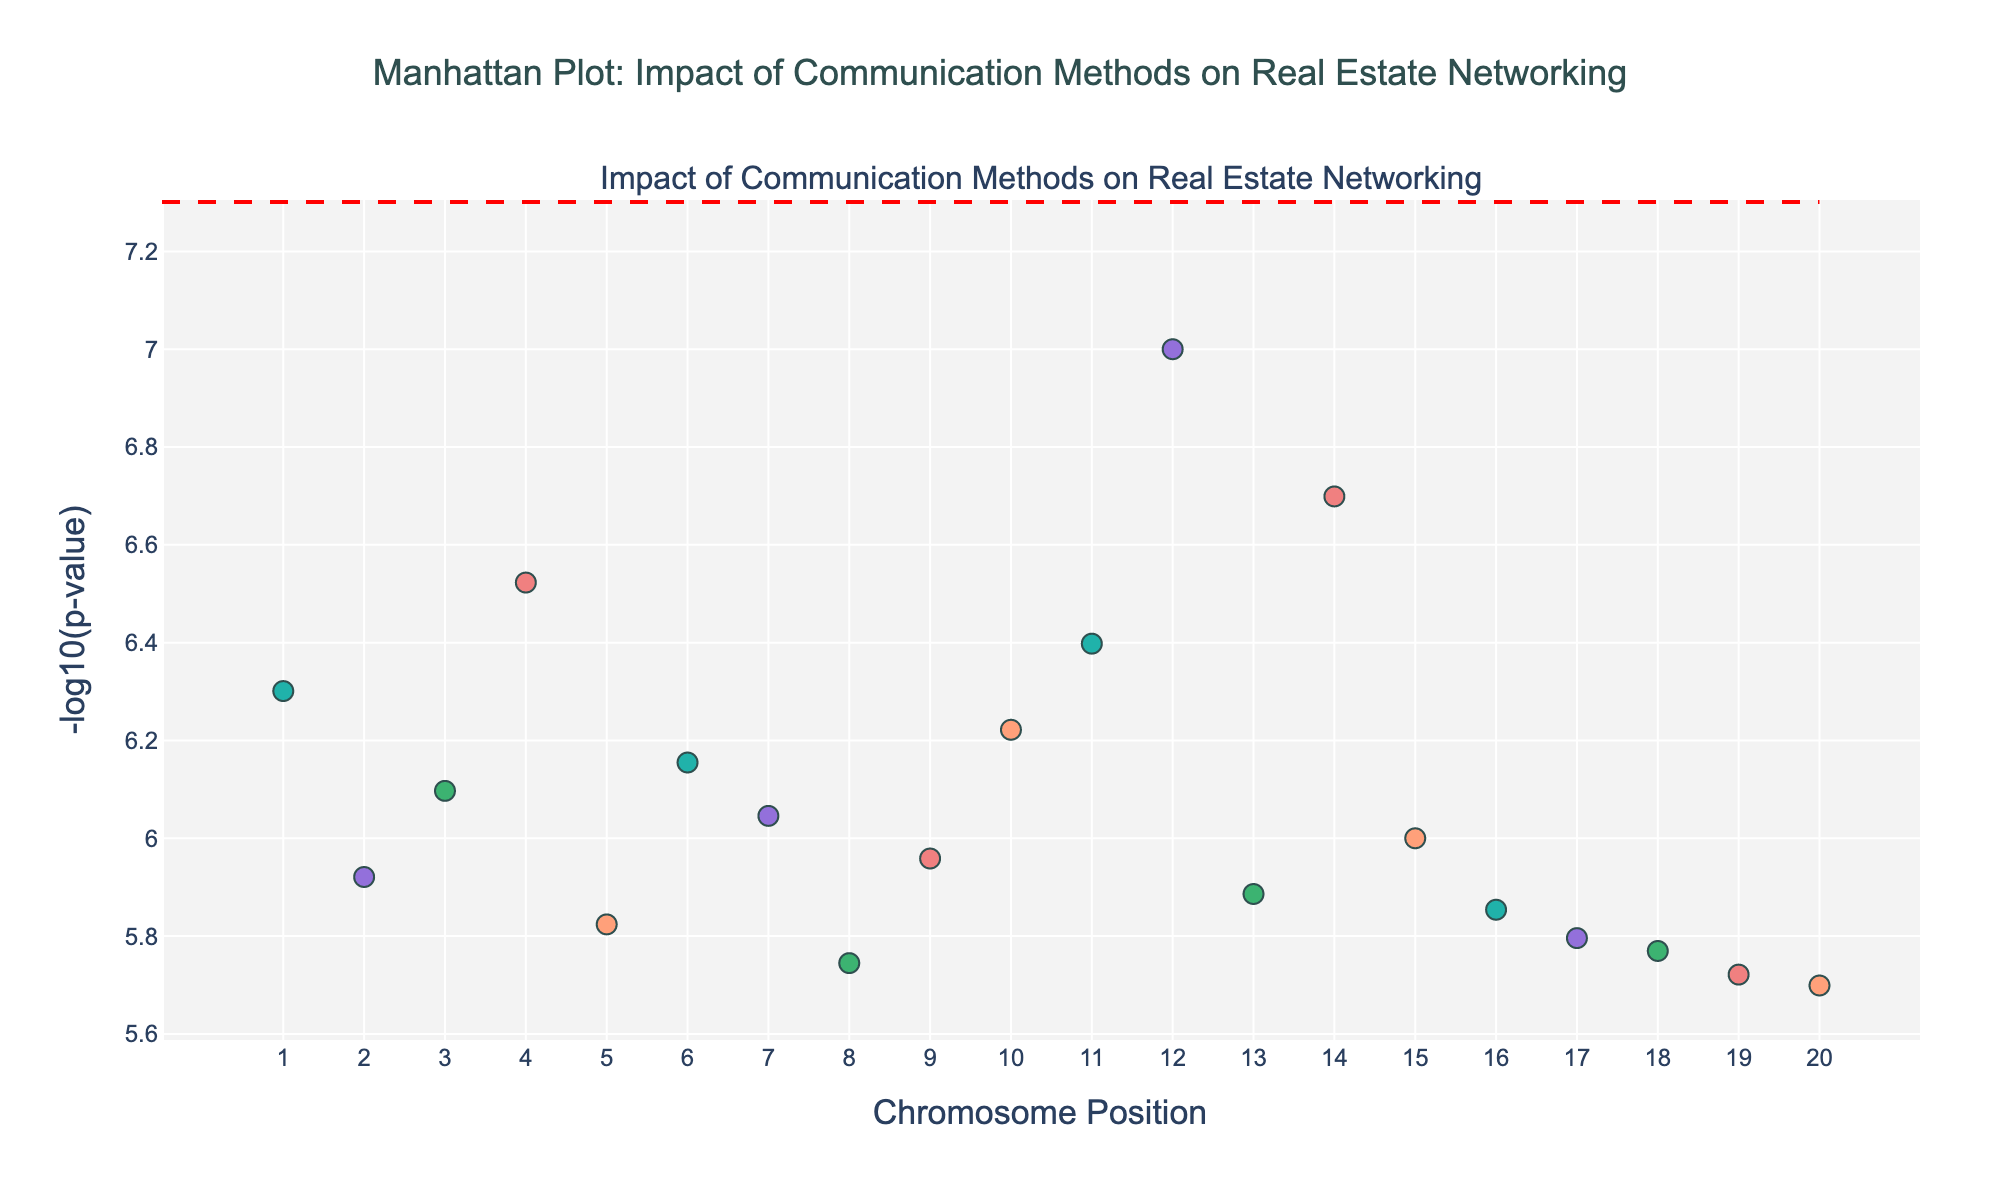How many chromosomes are shown in the figure? Look at the title and the x-axis, where there are labels indicating each chromosome number. Count these labels to determine the total number of chromosomes.
Answer: 20 What does the y-axis represent in the plot? The y-axis is labeled with '-log10(p-value)', which indicates the transformed statistical significance of each data point. The more significant the p-value, the higher the value on this axis.
Answer: -log10(p-value) Which data point has the highest significance level? Check the y-axis for the highest value and find the corresponding data point. The highest value represents the most significant p-value. In this case, observe the data point with the highest y-axis coordinate.
Answer: FACE_TO_FACE_MEETINGS Which chromosome has more than one data point? Look at each color-coded data point group on the plot and identify the chromosome numbers. The chromosomes that have multiple markers will be more prominent.
Answer: None Are there any data points with a p-value lower than 5e-8? The plot includes a horizontal dashed red line representing the p-value of 5e-8. Identify whether any data points are above this line. If they are, those data points have a p-value lower than 5e-8.
Answer: Yes What is the significance threshold represented by the red dashed line? Visually identify the horizontal red dashed line on the plot, and recall the mentioned significance threshold that the line represents.
Answer: 5e-8 Compare the significance of FACEBOOK_USE and PROPERTY_TOURS. Which one is more significant? Locate both FACEBOOK_USE and PROPERTY_TOURS on the plot, then compare their y-values. The higher the y-value, the more significant the data point.
Answer: FACEBOOK_USE How does the significance of EMAIL_MARKETING compare with TWITTER_ENGAGEMENT? Identify the positions of EMAIL_MARKETING and TWITTER_ENGAGEMENT on the y-axis and compare their heights to determine which has a higher significance.
Answer: TWITTER_ENGAGEMENT Which chromosome appears to have the least significant p-values among its data points? Examine the plot for the data points located lowest on the y-axis. Find which chromosome has the data point closest to the bottom of the plot.
Answer: 20 Does LINKEDIN_CONNECTIONS have a higher or lower significance than YOUTUBE_LIVESTREAMS? Locate the data points for LINKEDIN_CONNECTIONS and YOUTUBE_LIVESTREAMS, then compare their heights along the y-axis. The higher point indicates more significance.
Answer: Higher 